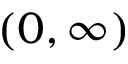Convert formula to latex. <formula><loc_0><loc_0><loc_500><loc_500>( 0 , \infty )</formula> 